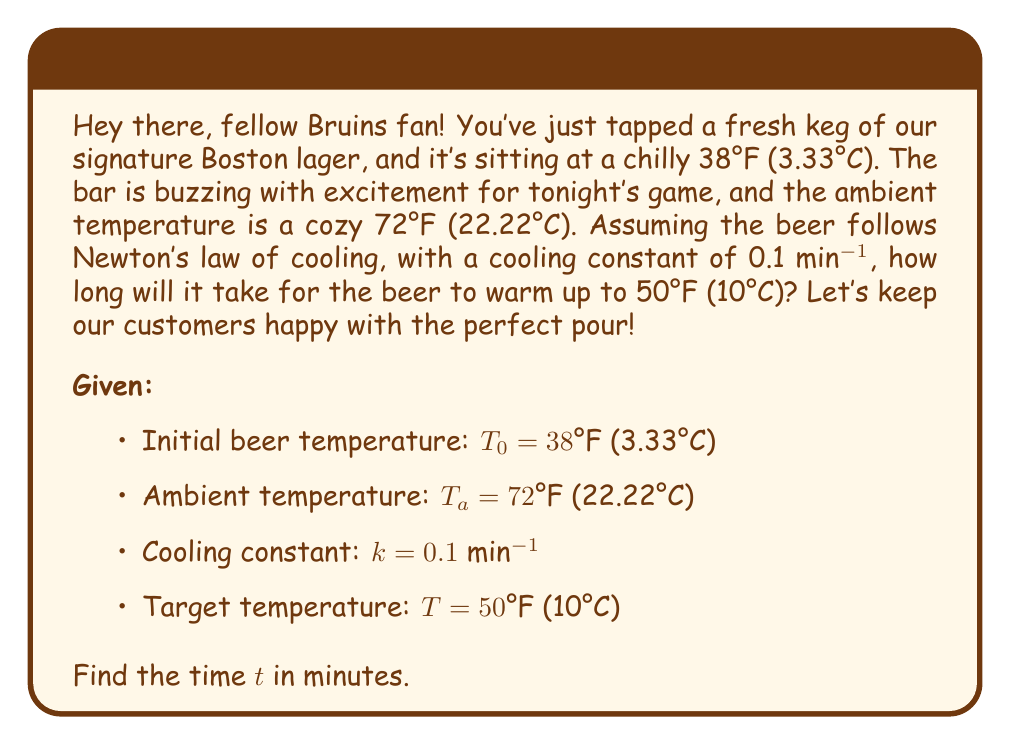Give your solution to this math problem. Alright, let's break this down like we're analyzing a Bruins power play:

1) Newton's law of cooling is given by the differential equation:

   $$\frac{dT}{dt} = -k(T - T_a)$$

   where $T$ is the temperature of the beer, $t$ is time, $k$ is the cooling constant, and $T_a$ is the ambient temperature.

2) The solution to this equation is:

   $$T(t) = T_a + (T_0 - T_a)e^{-kt}$$

3) We want to find $t$ when $T(t) = 50°F$. Let's plug in our values:

   $$50 = 72 + (38 - 72)e^{-0.1t}$$

4) Simplify:
   $$50 = 72 - 34e^{-0.1t}$$

5) Subtract 72 from both sides:
   $$-22 = -34e^{-0.1t}$$

6) Divide both sides by -34:
   $$\frac{22}{34} = e^{-0.1t}$$

7) Take the natural log of both sides:
   $$\ln(\frac{22}{34}) = -0.1t$$

8) Solve for $t$:
   $$t = -\frac{\ln(\frac{22}{34})}{0.1} \approx 43.57 \text{ minutes}$$

So, it'll take about 44 minutes for our beer to warm up to 50°F. Better keep an eye on those taps during the game!
Answer: Approximately 44 minutes 